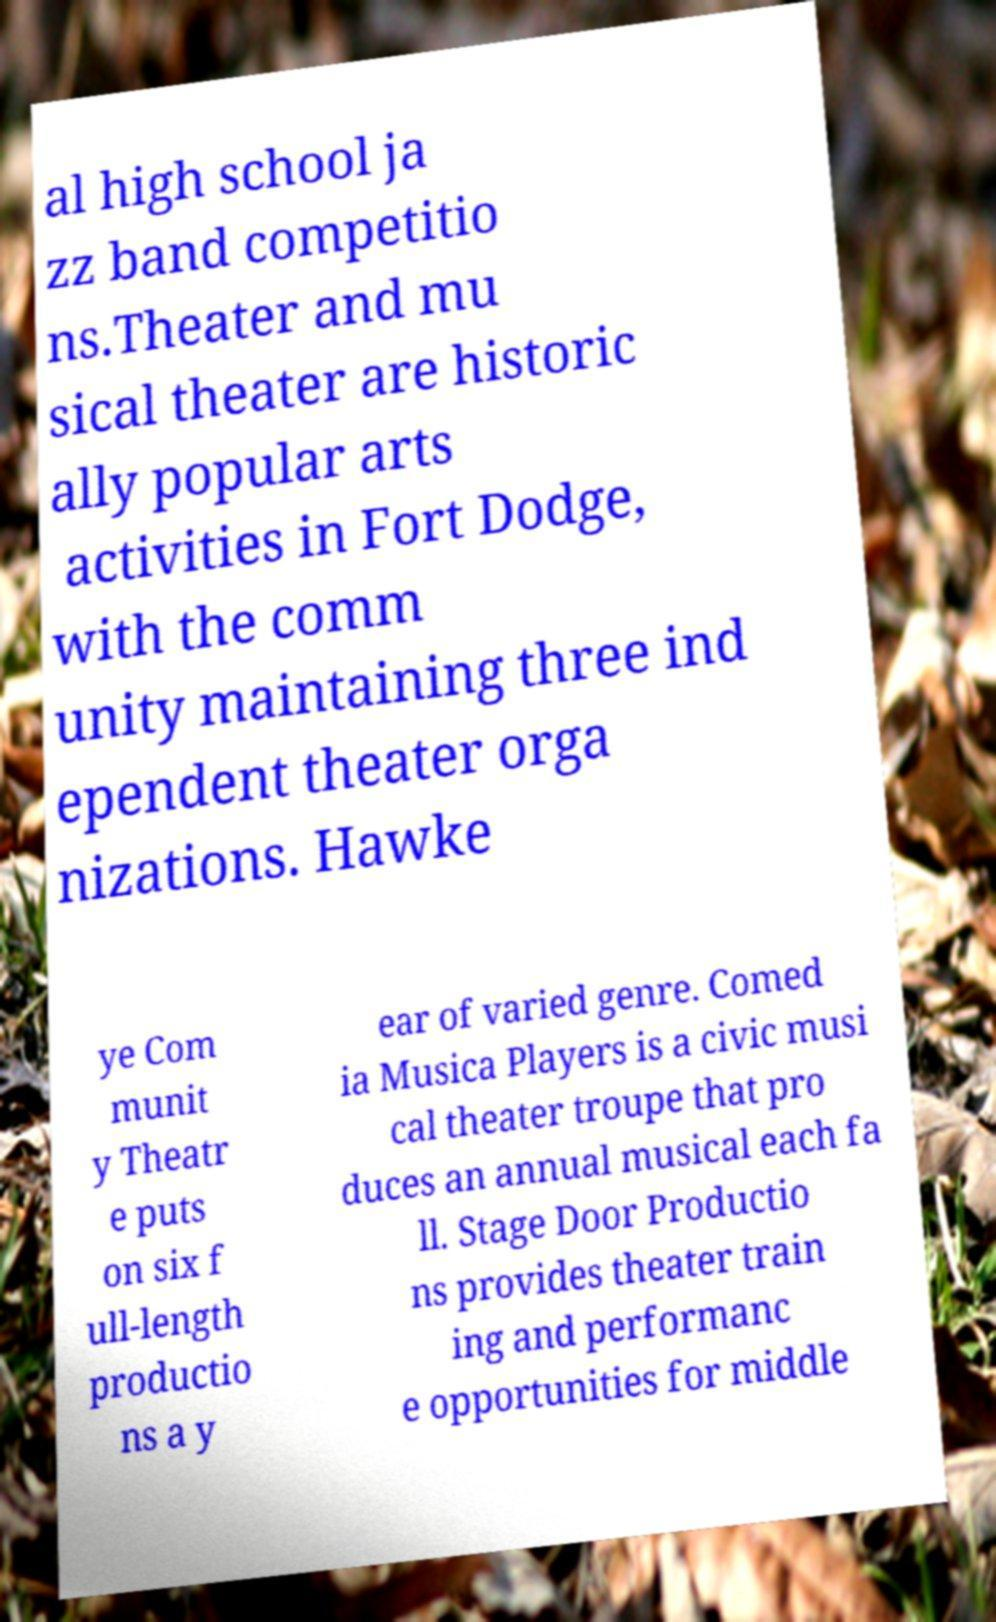I need the written content from this picture converted into text. Can you do that? al high school ja zz band competitio ns.Theater and mu sical theater are historic ally popular arts activities in Fort Dodge, with the comm unity maintaining three ind ependent theater orga nizations. Hawke ye Com munit y Theatr e puts on six f ull-length productio ns a y ear of varied genre. Comed ia Musica Players is a civic musi cal theater troupe that pro duces an annual musical each fa ll. Stage Door Productio ns provides theater train ing and performanc e opportunities for middle 